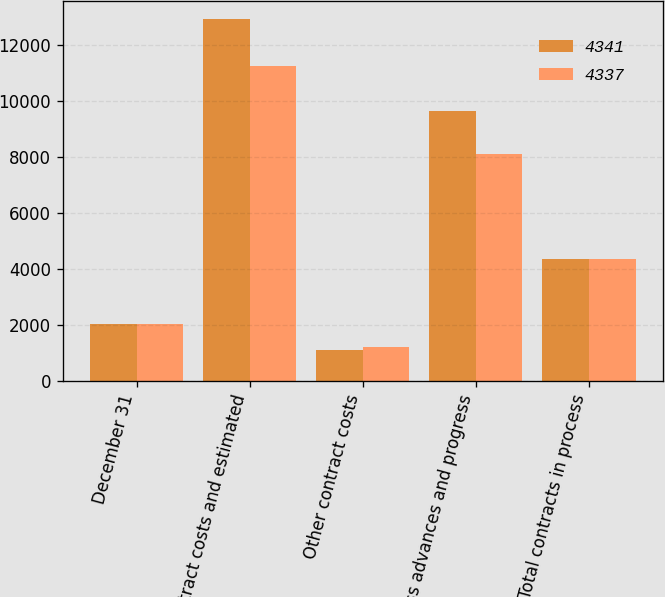Convert chart to OTSL. <chart><loc_0><loc_0><loc_500><loc_500><stacked_bar_chart><ecel><fcel>December 31<fcel>Contract costs and estimated<fcel>Other contract costs<fcel>Less advances and progress<fcel>Total contracts in process<nl><fcel>4341<fcel>2008<fcel>12904<fcel>1078<fcel>9641<fcel>4341<nl><fcel>4337<fcel>2007<fcel>11224<fcel>1200<fcel>8087<fcel>4337<nl></chart> 